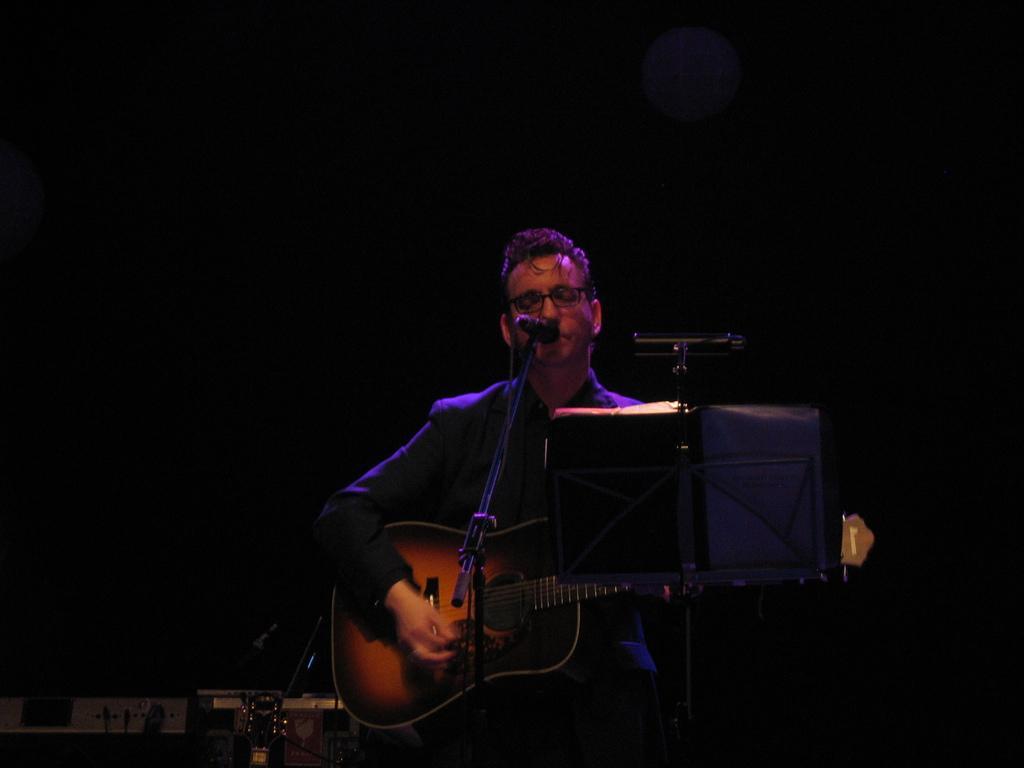In one or two sentences, can you explain what this image depicts? In the picture we can see a man standing and holding a guitar near the microphone, he is wearing a blazer. In the background we can see musical instruments in the dark. 